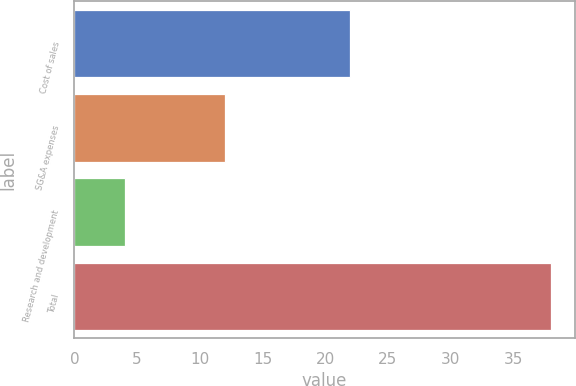Convert chart to OTSL. <chart><loc_0><loc_0><loc_500><loc_500><bar_chart><fcel>Cost of sales<fcel>SG&A expenses<fcel>Research and development<fcel>Total<nl><fcel>22<fcel>12<fcel>4<fcel>38<nl></chart> 